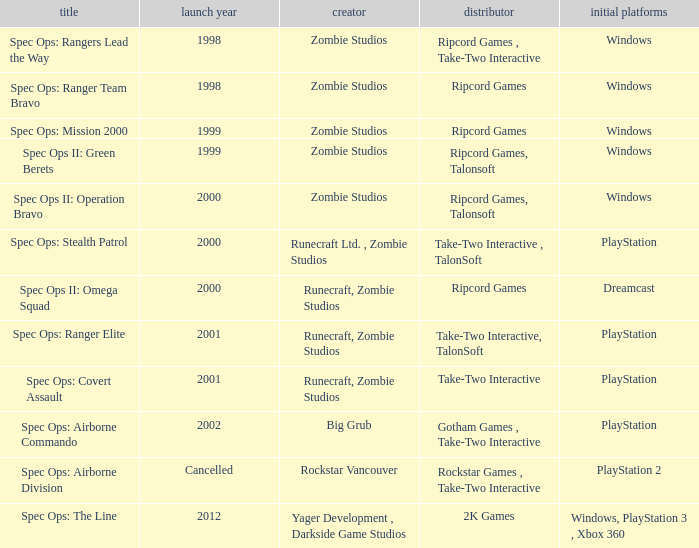Which publisher is responsible for spec ops: stealth patrol? Take-Two Interactive , TalonSoft. 